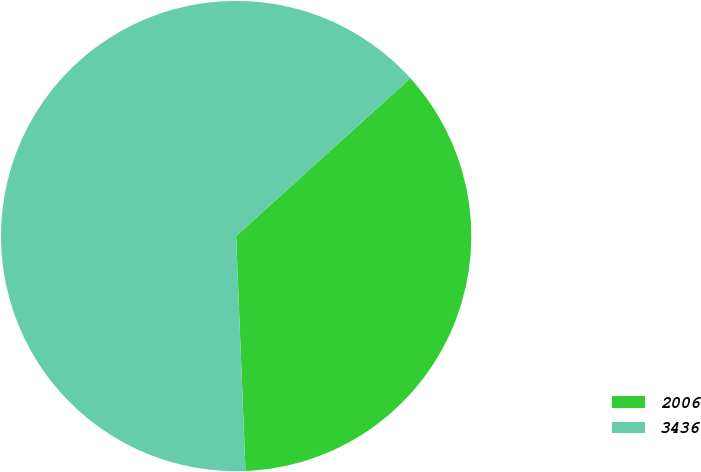<chart> <loc_0><loc_0><loc_500><loc_500><pie_chart><fcel>2006<fcel>3436<nl><fcel>36.08%<fcel>63.92%<nl></chart> 